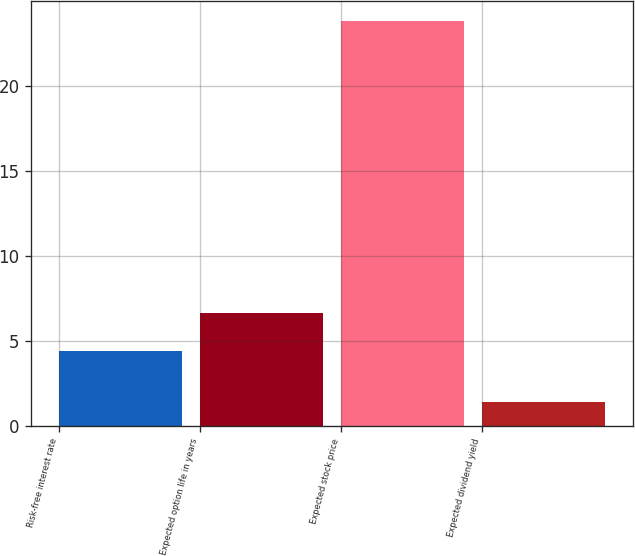Convert chart. <chart><loc_0><loc_0><loc_500><loc_500><bar_chart><fcel>Risk-free interest rate<fcel>Expected option life in years<fcel>Expected stock price<fcel>Expected dividend yield<nl><fcel>4.4<fcel>6.64<fcel>23.8<fcel>1.4<nl></chart> 